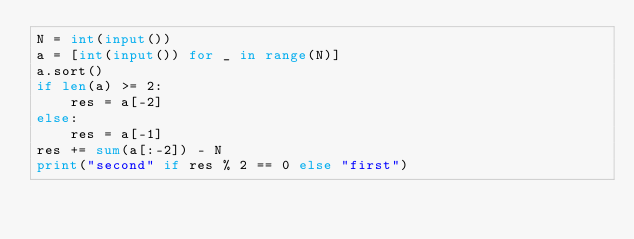<code> <loc_0><loc_0><loc_500><loc_500><_Python_>N = int(input())
a = [int(input()) for _ in range(N)]
a.sort()
if len(a) >= 2:
    res = a[-2]
else:
    res = a[-1]
res += sum(a[:-2]) - N
print("second" if res % 2 == 0 else "first")
</code> 